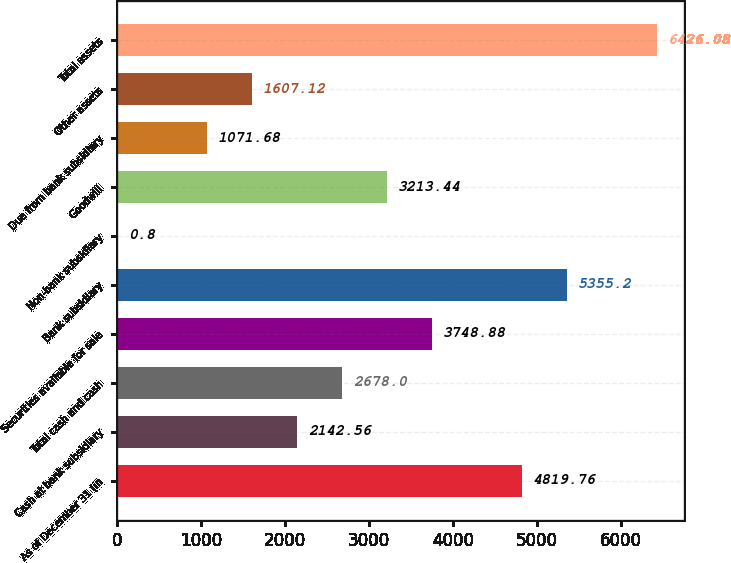Convert chart to OTSL. <chart><loc_0><loc_0><loc_500><loc_500><bar_chart><fcel>As of December 31 (in<fcel>Cash at bank subsidiary<fcel>Total cash and cash<fcel>Securities available for sale<fcel>Bank subsidiary<fcel>Non-bank subsidiary<fcel>Goodwill<fcel>Due from bank subsidiary<fcel>Other assets<fcel>Total assets<nl><fcel>4819.76<fcel>2142.56<fcel>2678<fcel>3748.88<fcel>5355.2<fcel>0.8<fcel>3213.44<fcel>1071.68<fcel>1607.12<fcel>6426.08<nl></chart> 